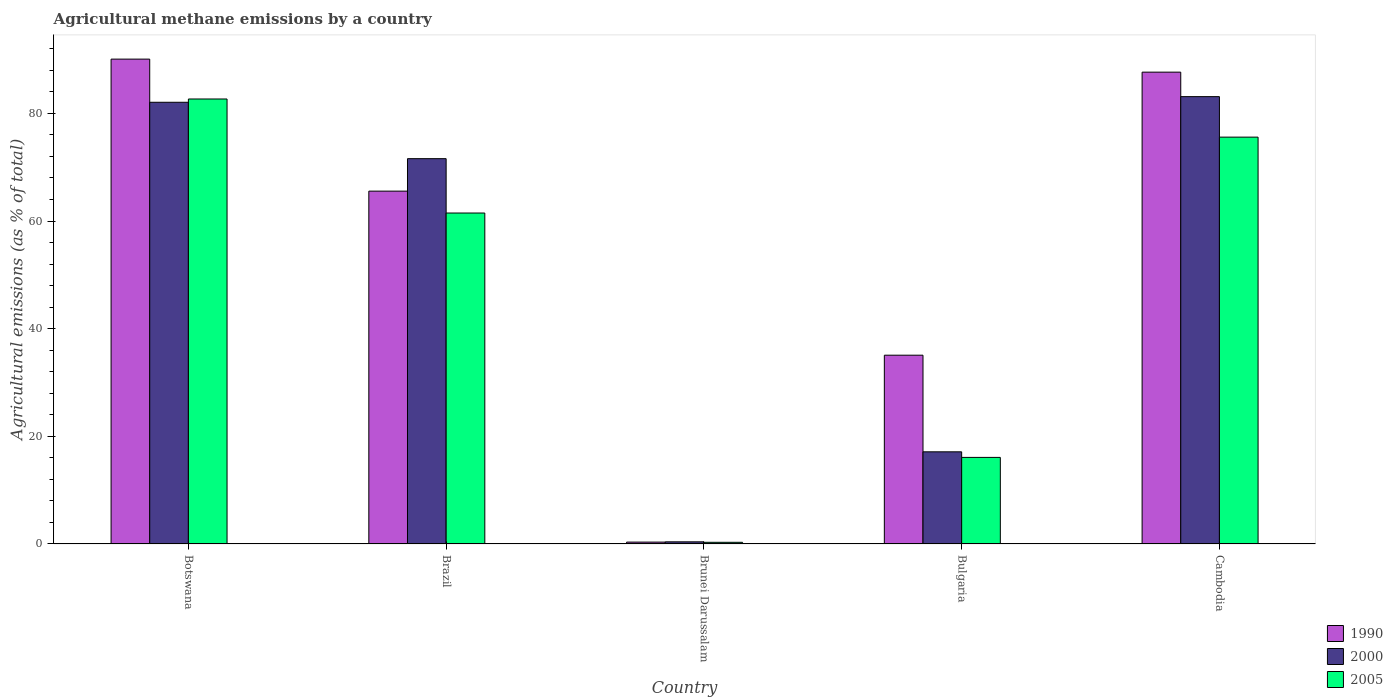How many different coloured bars are there?
Your answer should be very brief. 3. How many groups of bars are there?
Give a very brief answer. 5. Are the number of bars on each tick of the X-axis equal?
Offer a very short reply. Yes. How many bars are there on the 5th tick from the right?
Offer a very short reply. 3. In how many cases, is the number of bars for a given country not equal to the number of legend labels?
Provide a short and direct response. 0. What is the amount of agricultural methane emitted in 1990 in Botswana?
Make the answer very short. 90.08. Across all countries, what is the maximum amount of agricultural methane emitted in 1990?
Ensure brevity in your answer.  90.08. Across all countries, what is the minimum amount of agricultural methane emitted in 2005?
Make the answer very short. 0.31. In which country was the amount of agricultural methane emitted in 2005 maximum?
Offer a very short reply. Botswana. In which country was the amount of agricultural methane emitted in 2005 minimum?
Your answer should be compact. Brunei Darussalam. What is the total amount of agricultural methane emitted in 2005 in the graph?
Your answer should be very brief. 236.13. What is the difference between the amount of agricultural methane emitted in 2005 in Brunei Darussalam and that in Cambodia?
Your answer should be very brief. -75.27. What is the difference between the amount of agricultural methane emitted in 2005 in Brunei Darussalam and the amount of agricultural methane emitted in 2000 in Botswana?
Provide a short and direct response. -81.75. What is the average amount of agricultural methane emitted in 2000 per country?
Your answer should be compact. 50.85. What is the difference between the amount of agricultural methane emitted of/in 1990 and amount of agricultural methane emitted of/in 2000 in Cambodia?
Your response must be concise. 4.55. In how many countries, is the amount of agricultural methane emitted in 2000 greater than 56 %?
Your answer should be very brief. 3. What is the ratio of the amount of agricultural methane emitted in 2005 in Botswana to that in Bulgaria?
Give a very brief answer. 5.14. What is the difference between the highest and the second highest amount of agricultural methane emitted in 1990?
Your response must be concise. -24.53. What is the difference between the highest and the lowest amount of agricultural methane emitted in 1990?
Provide a succinct answer. 89.73. Is the sum of the amount of agricultural methane emitted in 2005 in Botswana and Bulgaria greater than the maximum amount of agricultural methane emitted in 1990 across all countries?
Provide a succinct answer. Yes. What does the 3rd bar from the left in Brazil represents?
Offer a very short reply. 2005. What does the 1st bar from the right in Brazil represents?
Your response must be concise. 2005. How many bars are there?
Give a very brief answer. 15. Are all the bars in the graph horizontal?
Your answer should be compact. No. Are the values on the major ticks of Y-axis written in scientific E-notation?
Ensure brevity in your answer.  No. Does the graph contain grids?
Make the answer very short. No. How are the legend labels stacked?
Make the answer very short. Vertical. What is the title of the graph?
Ensure brevity in your answer.  Agricultural methane emissions by a country. What is the label or title of the X-axis?
Offer a terse response. Country. What is the label or title of the Y-axis?
Your answer should be compact. Agricultural emissions (as % of total). What is the Agricultural emissions (as % of total) in 1990 in Botswana?
Give a very brief answer. 90.08. What is the Agricultural emissions (as % of total) of 2000 in Botswana?
Offer a very short reply. 82.06. What is the Agricultural emissions (as % of total) in 2005 in Botswana?
Keep it short and to the point. 82.67. What is the Agricultural emissions (as % of total) in 1990 in Brazil?
Provide a succinct answer. 65.55. What is the Agricultural emissions (as % of total) in 2000 in Brazil?
Offer a very short reply. 71.58. What is the Agricultural emissions (as % of total) of 2005 in Brazil?
Ensure brevity in your answer.  61.48. What is the Agricultural emissions (as % of total) in 1990 in Brunei Darussalam?
Your response must be concise. 0.35. What is the Agricultural emissions (as % of total) of 2000 in Brunei Darussalam?
Offer a very short reply. 0.4. What is the Agricultural emissions (as % of total) of 2005 in Brunei Darussalam?
Make the answer very short. 0.31. What is the Agricultural emissions (as % of total) in 1990 in Bulgaria?
Provide a succinct answer. 35.07. What is the Agricultural emissions (as % of total) in 2000 in Bulgaria?
Your response must be concise. 17.12. What is the Agricultural emissions (as % of total) of 2005 in Bulgaria?
Offer a terse response. 16.08. What is the Agricultural emissions (as % of total) of 1990 in Cambodia?
Your answer should be compact. 87.66. What is the Agricultural emissions (as % of total) in 2000 in Cambodia?
Give a very brief answer. 83.11. What is the Agricultural emissions (as % of total) in 2005 in Cambodia?
Provide a succinct answer. 75.58. Across all countries, what is the maximum Agricultural emissions (as % of total) in 1990?
Give a very brief answer. 90.08. Across all countries, what is the maximum Agricultural emissions (as % of total) in 2000?
Offer a terse response. 83.11. Across all countries, what is the maximum Agricultural emissions (as % of total) of 2005?
Give a very brief answer. 82.67. Across all countries, what is the minimum Agricultural emissions (as % of total) of 1990?
Your answer should be very brief. 0.35. Across all countries, what is the minimum Agricultural emissions (as % of total) in 2000?
Provide a succinct answer. 0.4. Across all countries, what is the minimum Agricultural emissions (as % of total) of 2005?
Ensure brevity in your answer.  0.31. What is the total Agricultural emissions (as % of total) of 1990 in the graph?
Your response must be concise. 278.7. What is the total Agricultural emissions (as % of total) of 2000 in the graph?
Offer a terse response. 254.26. What is the total Agricultural emissions (as % of total) of 2005 in the graph?
Offer a very short reply. 236.13. What is the difference between the Agricultural emissions (as % of total) in 1990 in Botswana and that in Brazil?
Your answer should be compact. 24.53. What is the difference between the Agricultural emissions (as % of total) of 2000 in Botswana and that in Brazil?
Your answer should be compact. 10.48. What is the difference between the Agricultural emissions (as % of total) of 2005 in Botswana and that in Brazil?
Your answer should be compact. 21.18. What is the difference between the Agricultural emissions (as % of total) in 1990 in Botswana and that in Brunei Darussalam?
Give a very brief answer. 89.73. What is the difference between the Agricultural emissions (as % of total) in 2000 in Botswana and that in Brunei Darussalam?
Give a very brief answer. 81.66. What is the difference between the Agricultural emissions (as % of total) of 2005 in Botswana and that in Brunei Darussalam?
Give a very brief answer. 82.36. What is the difference between the Agricultural emissions (as % of total) in 1990 in Botswana and that in Bulgaria?
Your answer should be very brief. 55. What is the difference between the Agricultural emissions (as % of total) of 2000 in Botswana and that in Bulgaria?
Ensure brevity in your answer.  64.94. What is the difference between the Agricultural emissions (as % of total) of 2005 in Botswana and that in Bulgaria?
Provide a succinct answer. 66.58. What is the difference between the Agricultural emissions (as % of total) of 1990 in Botswana and that in Cambodia?
Keep it short and to the point. 2.42. What is the difference between the Agricultural emissions (as % of total) in 2000 in Botswana and that in Cambodia?
Your answer should be compact. -1.05. What is the difference between the Agricultural emissions (as % of total) in 2005 in Botswana and that in Cambodia?
Your answer should be very brief. 7.09. What is the difference between the Agricultural emissions (as % of total) in 1990 in Brazil and that in Brunei Darussalam?
Ensure brevity in your answer.  65.2. What is the difference between the Agricultural emissions (as % of total) of 2000 in Brazil and that in Brunei Darussalam?
Your response must be concise. 71.19. What is the difference between the Agricultural emissions (as % of total) in 2005 in Brazil and that in Brunei Darussalam?
Offer a very short reply. 61.17. What is the difference between the Agricultural emissions (as % of total) in 1990 in Brazil and that in Bulgaria?
Provide a succinct answer. 30.48. What is the difference between the Agricultural emissions (as % of total) of 2000 in Brazil and that in Bulgaria?
Keep it short and to the point. 54.46. What is the difference between the Agricultural emissions (as % of total) of 2005 in Brazil and that in Bulgaria?
Offer a terse response. 45.4. What is the difference between the Agricultural emissions (as % of total) in 1990 in Brazil and that in Cambodia?
Your answer should be compact. -22.11. What is the difference between the Agricultural emissions (as % of total) in 2000 in Brazil and that in Cambodia?
Offer a very short reply. -11.52. What is the difference between the Agricultural emissions (as % of total) in 2005 in Brazil and that in Cambodia?
Your answer should be very brief. -14.1. What is the difference between the Agricultural emissions (as % of total) of 1990 in Brunei Darussalam and that in Bulgaria?
Offer a terse response. -34.72. What is the difference between the Agricultural emissions (as % of total) in 2000 in Brunei Darussalam and that in Bulgaria?
Provide a succinct answer. -16.72. What is the difference between the Agricultural emissions (as % of total) in 2005 in Brunei Darussalam and that in Bulgaria?
Offer a very short reply. -15.77. What is the difference between the Agricultural emissions (as % of total) of 1990 in Brunei Darussalam and that in Cambodia?
Give a very brief answer. -87.31. What is the difference between the Agricultural emissions (as % of total) of 2000 in Brunei Darussalam and that in Cambodia?
Give a very brief answer. -82.71. What is the difference between the Agricultural emissions (as % of total) in 2005 in Brunei Darussalam and that in Cambodia?
Your answer should be very brief. -75.27. What is the difference between the Agricultural emissions (as % of total) of 1990 in Bulgaria and that in Cambodia?
Provide a succinct answer. -52.58. What is the difference between the Agricultural emissions (as % of total) in 2000 in Bulgaria and that in Cambodia?
Your answer should be compact. -65.99. What is the difference between the Agricultural emissions (as % of total) of 2005 in Bulgaria and that in Cambodia?
Provide a succinct answer. -59.5. What is the difference between the Agricultural emissions (as % of total) in 1990 in Botswana and the Agricultural emissions (as % of total) in 2000 in Brazil?
Give a very brief answer. 18.49. What is the difference between the Agricultural emissions (as % of total) of 1990 in Botswana and the Agricultural emissions (as % of total) of 2005 in Brazil?
Your answer should be compact. 28.59. What is the difference between the Agricultural emissions (as % of total) in 2000 in Botswana and the Agricultural emissions (as % of total) in 2005 in Brazil?
Provide a succinct answer. 20.57. What is the difference between the Agricultural emissions (as % of total) in 1990 in Botswana and the Agricultural emissions (as % of total) in 2000 in Brunei Darussalam?
Your answer should be very brief. 89.68. What is the difference between the Agricultural emissions (as % of total) in 1990 in Botswana and the Agricultural emissions (as % of total) in 2005 in Brunei Darussalam?
Provide a succinct answer. 89.77. What is the difference between the Agricultural emissions (as % of total) of 2000 in Botswana and the Agricultural emissions (as % of total) of 2005 in Brunei Darussalam?
Offer a very short reply. 81.75. What is the difference between the Agricultural emissions (as % of total) in 1990 in Botswana and the Agricultural emissions (as % of total) in 2000 in Bulgaria?
Provide a short and direct response. 72.96. What is the difference between the Agricultural emissions (as % of total) in 1990 in Botswana and the Agricultural emissions (as % of total) in 2005 in Bulgaria?
Offer a terse response. 73.99. What is the difference between the Agricultural emissions (as % of total) of 2000 in Botswana and the Agricultural emissions (as % of total) of 2005 in Bulgaria?
Ensure brevity in your answer.  65.97. What is the difference between the Agricultural emissions (as % of total) in 1990 in Botswana and the Agricultural emissions (as % of total) in 2000 in Cambodia?
Keep it short and to the point. 6.97. What is the difference between the Agricultural emissions (as % of total) of 1990 in Botswana and the Agricultural emissions (as % of total) of 2005 in Cambodia?
Your response must be concise. 14.49. What is the difference between the Agricultural emissions (as % of total) of 2000 in Botswana and the Agricultural emissions (as % of total) of 2005 in Cambodia?
Your answer should be compact. 6.48. What is the difference between the Agricultural emissions (as % of total) of 1990 in Brazil and the Agricultural emissions (as % of total) of 2000 in Brunei Darussalam?
Provide a succinct answer. 65.15. What is the difference between the Agricultural emissions (as % of total) of 1990 in Brazil and the Agricultural emissions (as % of total) of 2005 in Brunei Darussalam?
Provide a short and direct response. 65.24. What is the difference between the Agricultural emissions (as % of total) of 2000 in Brazil and the Agricultural emissions (as % of total) of 2005 in Brunei Darussalam?
Provide a succinct answer. 71.27. What is the difference between the Agricultural emissions (as % of total) of 1990 in Brazil and the Agricultural emissions (as % of total) of 2000 in Bulgaria?
Your answer should be compact. 48.43. What is the difference between the Agricultural emissions (as % of total) of 1990 in Brazil and the Agricultural emissions (as % of total) of 2005 in Bulgaria?
Offer a very short reply. 49.47. What is the difference between the Agricultural emissions (as % of total) of 2000 in Brazil and the Agricultural emissions (as % of total) of 2005 in Bulgaria?
Provide a succinct answer. 55.5. What is the difference between the Agricultural emissions (as % of total) in 1990 in Brazil and the Agricultural emissions (as % of total) in 2000 in Cambodia?
Offer a very short reply. -17.56. What is the difference between the Agricultural emissions (as % of total) in 1990 in Brazil and the Agricultural emissions (as % of total) in 2005 in Cambodia?
Offer a very short reply. -10.03. What is the difference between the Agricultural emissions (as % of total) of 2000 in Brazil and the Agricultural emissions (as % of total) of 2005 in Cambodia?
Your answer should be compact. -4. What is the difference between the Agricultural emissions (as % of total) in 1990 in Brunei Darussalam and the Agricultural emissions (as % of total) in 2000 in Bulgaria?
Your response must be concise. -16.77. What is the difference between the Agricultural emissions (as % of total) in 1990 in Brunei Darussalam and the Agricultural emissions (as % of total) in 2005 in Bulgaria?
Offer a terse response. -15.74. What is the difference between the Agricultural emissions (as % of total) in 2000 in Brunei Darussalam and the Agricultural emissions (as % of total) in 2005 in Bulgaria?
Offer a terse response. -15.69. What is the difference between the Agricultural emissions (as % of total) of 1990 in Brunei Darussalam and the Agricultural emissions (as % of total) of 2000 in Cambodia?
Your response must be concise. -82.76. What is the difference between the Agricultural emissions (as % of total) in 1990 in Brunei Darussalam and the Agricultural emissions (as % of total) in 2005 in Cambodia?
Give a very brief answer. -75.23. What is the difference between the Agricultural emissions (as % of total) in 2000 in Brunei Darussalam and the Agricultural emissions (as % of total) in 2005 in Cambodia?
Give a very brief answer. -75.19. What is the difference between the Agricultural emissions (as % of total) of 1990 in Bulgaria and the Agricultural emissions (as % of total) of 2000 in Cambodia?
Keep it short and to the point. -48.03. What is the difference between the Agricultural emissions (as % of total) of 1990 in Bulgaria and the Agricultural emissions (as % of total) of 2005 in Cambodia?
Make the answer very short. -40.51. What is the difference between the Agricultural emissions (as % of total) in 2000 in Bulgaria and the Agricultural emissions (as % of total) in 2005 in Cambodia?
Your answer should be very brief. -58.46. What is the average Agricultural emissions (as % of total) of 1990 per country?
Your response must be concise. 55.74. What is the average Agricultural emissions (as % of total) of 2000 per country?
Your response must be concise. 50.85. What is the average Agricultural emissions (as % of total) in 2005 per country?
Your response must be concise. 47.23. What is the difference between the Agricultural emissions (as % of total) in 1990 and Agricultural emissions (as % of total) in 2000 in Botswana?
Offer a very short reply. 8.02. What is the difference between the Agricultural emissions (as % of total) of 1990 and Agricultural emissions (as % of total) of 2005 in Botswana?
Ensure brevity in your answer.  7.41. What is the difference between the Agricultural emissions (as % of total) in 2000 and Agricultural emissions (as % of total) in 2005 in Botswana?
Give a very brief answer. -0.61. What is the difference between the Agricultural emissions (as % of total) in 1990 and Agricultural emissions (as % of total) in 2000 in Brazil?
Your response must be concise. -6.03. What is the difference between the Agricultural emissions (as % of total) of 1990 and Agricultural emissions (as % of total) of 2005 in Brazil?
Your response must be concise. 4.07. What is the difference between the Agricultural emissions (as % of total) of 2000 and Agricultural emissions (as % of total) of 2005 in Brazil?
Ensure brevity in your answer.  10.1. What is the difference between the Agricultural emissions (as % of total) of 1990 and Agricultural emissions (as % of total) of 2000 in Brunei Darussalam?
Keep it short and to the point. -0.05. What is the difference between the Agricultural emissions (as % of total) of 1990 and Agricultural emissions (as % of total) of 2005 in Brunei Darussalam?
Provide a short and direct response. 0.04. What is the difference between the Agricultural emissions (as % of total) in 2000 and Agricultural emissions (as % of total) in 2005 in Brunei Darussalam?
Your answer should be very brief. 0.09. What is the difference between the Agricultural emissions (as % of total) in 1990 and Agricultural emissions (as % of total) in 2000 in Bulgaria?
Offer a terse response. 17.95. What is the difference between the Agricultural emissions (as % of total) in 1990 and Agricultural emissions (as % of total) in 2005 in Bulgaria?
Give a very brief answer. 18.99. What is the difference between the Agricultural emissions (as % of total) of 2000 and Agricultural emissions (as % of total) of 2005 in Bulgaria?
Your response must be concise. 1.04. What is the difference between the Agricultural emissions (as % of total) of 1990 and Agricultural emissions (as % of total) of 2000 in Cambodia?
Offer a very short reply. 4.55. What is the difference between the Agricultural emissions (as % of total) in 1990 and Agricultural emissions (as % of total) in 2005 in Cambodia?
Offer a terse response. 12.07. What is the difference between the Agricultural emissions (as % of total) in 2000 and Agricultural emissions (as % of total) in 2005 in Cambodia?
Keep it short and to the point. 7.52. What is the ratio of the Agricultural emissions (as % of total) in 1990 in Botswana to that in Brazil?
Your answer should be very brief. 1.37. What is the ratio of the Agricultural emissions (as % of total) of 2000 in Botswana to that in Brazil?
Your response must be concise. 1.15. What is the ratio of the Agricultural emissions (as % of total) of 2005 in Botswana to that in Brazil?
Ensure brevity in your answer.  1.34. What is the ratio of the Agricultural emissions (as % of total) of 1990 in Botswana to that in Brunei Darussalam?
Provide a succinct answer. 258.83. What is the ratio of the Agricultural emissions (as % of total) of 2000 in Botswana to that in Brunei Darussalam?
Make the answer very short. 206.9. What is the ratio of the Agricultural emissions (as % of total) in 2005 in Botswana to that in Brunei Darussalam?
Your response must be concise. 266.37. What is the ratio of the Agricultural emissions (as % of total) in 1990 in Botswana to that in Bulgaria?
Ensure brevity in your answer.  2.57. What is the ratio of the Agricultural emissions (as % of total) in 2000 in Botswana to that in Bulgaria?
Your answer should be very brief. 4.79. What is the ratio of the Agricultural emissions (as % of total) in 2005 in Botswana to that in Bulgaria?
Give a very brief answer. 5.14. What is the ratio of the Agricultural emissions (as % of total) of 1990 in Botswana to that in Cambodia?
Your response must be concise. 1.03. What is the ratio of the Agricultural emissions (as % of total) of 2000 in Botswana to that in Cambodia?
Provide a short and direct response. 0.99. What is the ratio of the Agricultural emissions (as % of total) in 2005 in Botswana to that in Cambodia?
Provide a short and direct response. 1.09. What is the ratio of the Agricultural emissions (as % of total) of 1990 in Brazil to that in Brunei Darussalam?
Give a very brief answer. 188.36. What is the ratio of the Agricultural emissions (as % of total) in 2000 in Brazil to that in Brunei Darussalam?
Give a very brief answer. 180.49. What is the ratio of the Agricultural emissions (as % of total) in 2005 in Brazil to that in Brunei Darussalam?
Your answer should be very brief. 198.11. What is the ratio of the Agricultural emissions (as % of total) in 1990 in Brazil to that in Bulgaria?
Give a very brief answer. 1.87. What is the ratio of the Agricultural emissions (as % of total) in 2000 in Brazil to that in Bulgaria?
Offer a terse response. 4.18. What is the ratio of the Agricultural emissions (as % of total) of 2005 in Brazil to that in Bulgaria?
Provide a short and direct response. 3.82. What is the ratio of the Agricultural emissions (as % of total) of 1990 in Brazil to that in Cambodia?
Offer a very short reply. 0.75. What is the ratio of the Agricultural emissions (as % of total) in 2000 in Brazil to that in Cambodia?
Ensure brevity in your answer.  0.86. What is the ratio of the Agricultural emissions (as % of total) of 2005 in Brazil to that in Cambodia?
Give a very brief answer. 0.81. What is the ratio of the Agricultural emissions (as % of total) in 1990 in Brunei Darussalam to that in Bulgaria?
Your answer should be very brief. 0.01. What is the ratio of the Agricultural emissions (as % of total) in 2000 in Brunei Darussalam to that in Bulgaria?
Your answer should be very brief. 0.02. What is the ratio of the Agricultural emissions (as % of total) in 2005 in Brunei Darussalam to that in Bulgaria?
Provide a short and direct response. 0.02. What is the ratio of the Agricultural emissions (as % of total) in 1990 in Brunei Darussalam to that in Cambodia?
Your answer should be very brief. 0. What is the ratio of the Agricultural emissions (as % of total) in 2000 in Brunei Darussalam to that in Cambodia?
Your answer should be compact. 0. What is the ratio of the Agricultural emissions (as % of total) of 2005 in Brunei Darussalam to that in Cambodia?
Offer a terse response. 0. What is the ratio of the Agricultural emissions (as % of total) of 1990 in Bulgaria to that in Cambodia?
Your response must be concise. 0.4. What is the ratio of the Agricultural emissions (as % of total) of 2000 in Bulgaria to that in Cambodia?
Offer a very short reply. 0.21. What is the ratio of the Agricultural emissions (as % of total) of 2005 in Bulgaria to that in Cambodia?
Offer a terse response. 0.21. What is the difference between the highest and the second highest Agricultural emissions (as % of total) of 1990?
Provide a succinct answer. 2.42. What is the difference between the highest and the second highest Agricultural emissions (as % of total) of 2000?
Your response must be concise. 1.05. What is the difference between the highest and the second highest Agricultural emissions (as % of total) in 2005?
Make the answer very short. 7.09. What is the difference between the highest and the lowest Agricultural emissions (as % of total) of 1990?
Keep it short and to the point. 89.73. What is the difference between the highest and the lowest Agricultural emissions (as % of total) of 2000?
Your answer should be compact. 82.71. What is the difference between the highest and the lowest Agricultural emissions (as % of total) in 2005?
Your answer should be very brief. 82.36. 